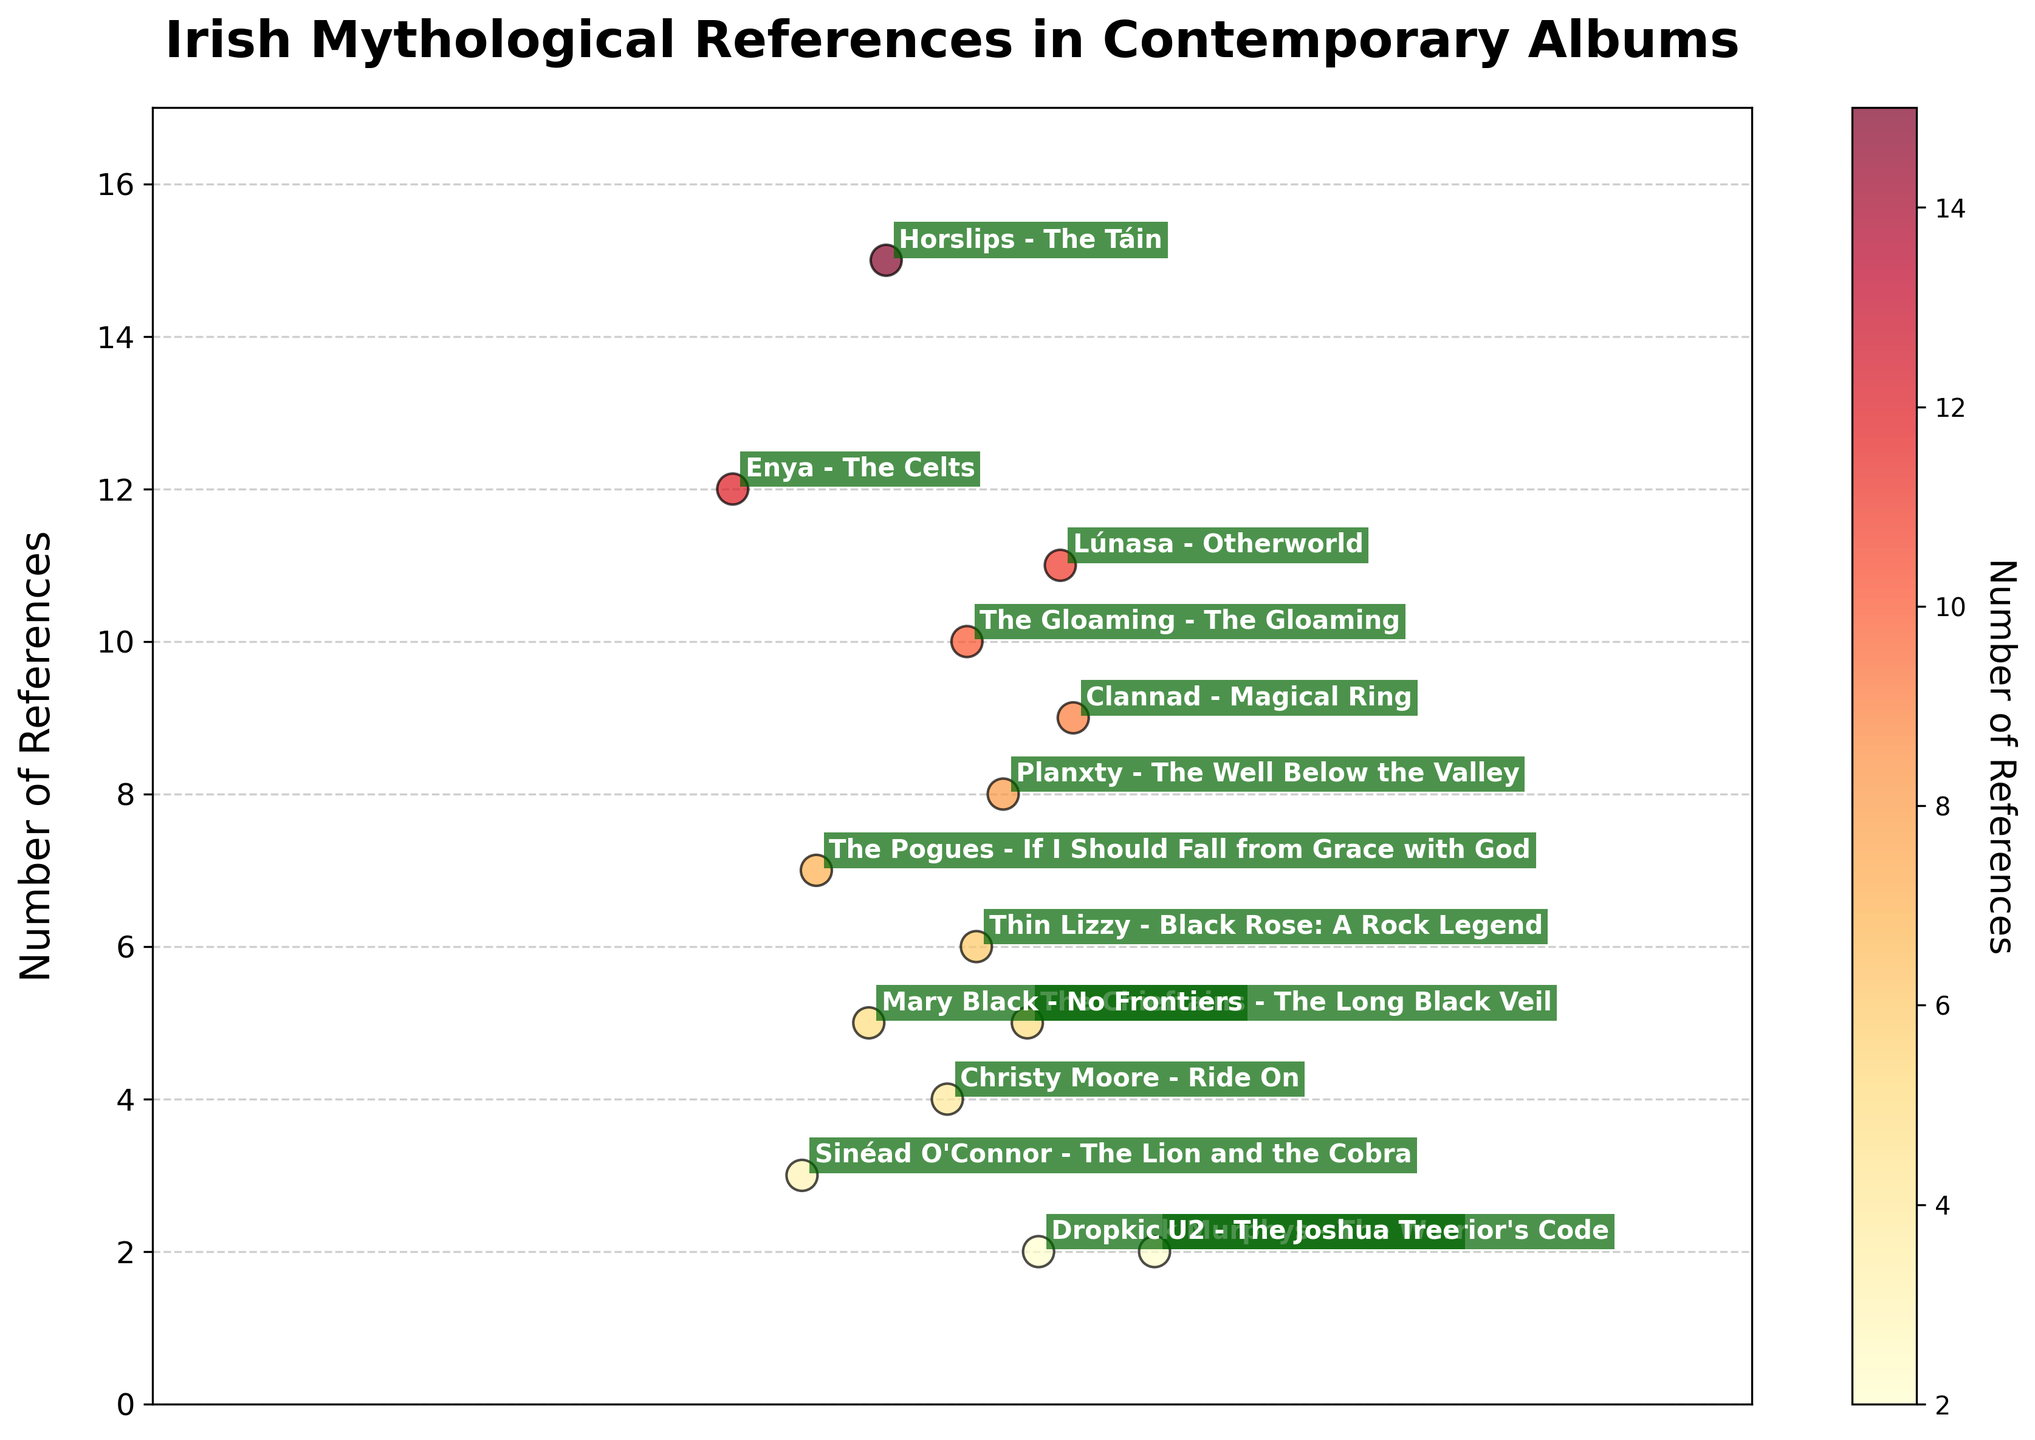What is the title of the figure? The title of the figure is typically displayed at the top, providing an overview of what the plot illustrates. Here, it is at the top of the figure in bold and large font.
Answer: Irish Mythological References in Contemporary Albums How many albums have exactly 5 references? Identify the data points labeled with 5 references and count them. The figure includes annotations for each album, making it easy to spot the relevant ones.
Answer: 2 Which album has the highest number of mythological references? Look for the data point at the topmost value on the y-axis and read the associated annotation.
Answer: "Horslips - The Táin" What is the color range used in the colorbar? Examine the colorbar next to the plot which represents the range of values. Colors range from light yellow to dark red, indicating the number of references.
Answer: Light yellow to dark red What is the total number of references for albums by Enya and Lúnasa combined? Locate and read the number of references for both Enya and Lúnasa and then add these values. Enya has 12 and Lúnasa has 11.
Answer: 23 How many references does "Planxty - The Well Below the Valley" have compared to "Mary Black - No Frontiers"? Read the annotations for both data points. "Planxty - The Well Below the Valley" has 8 references and "Mary Black - No Frontiers" has 5 references.
Answer: 3 more Which albums have fewer than 4 references? Identify and list all the data points that fall below the 4 references mark on the y-axis.
Answer: "Sinéad O'Connor - The Lion and the Cobra" and "Dropkick Murphys - The Warrior's Code" and "U2 - The Joshua Tree" What is the average number of references per album? Sum all the reference counts and divide by the total number of albums. (7 + 12 + 5 + 9 + 15 + 6 + 3 + 8 + 4 + 11 + 2 + 10 + 2 + 5) / 14 = 89 / 14.
Answer: 6.36 What is the median number of references? Sort the data points by the number of references and find the middle value. With 14 albums, the median will be the average of the 7th and 8th values.
Answer: 6.5 